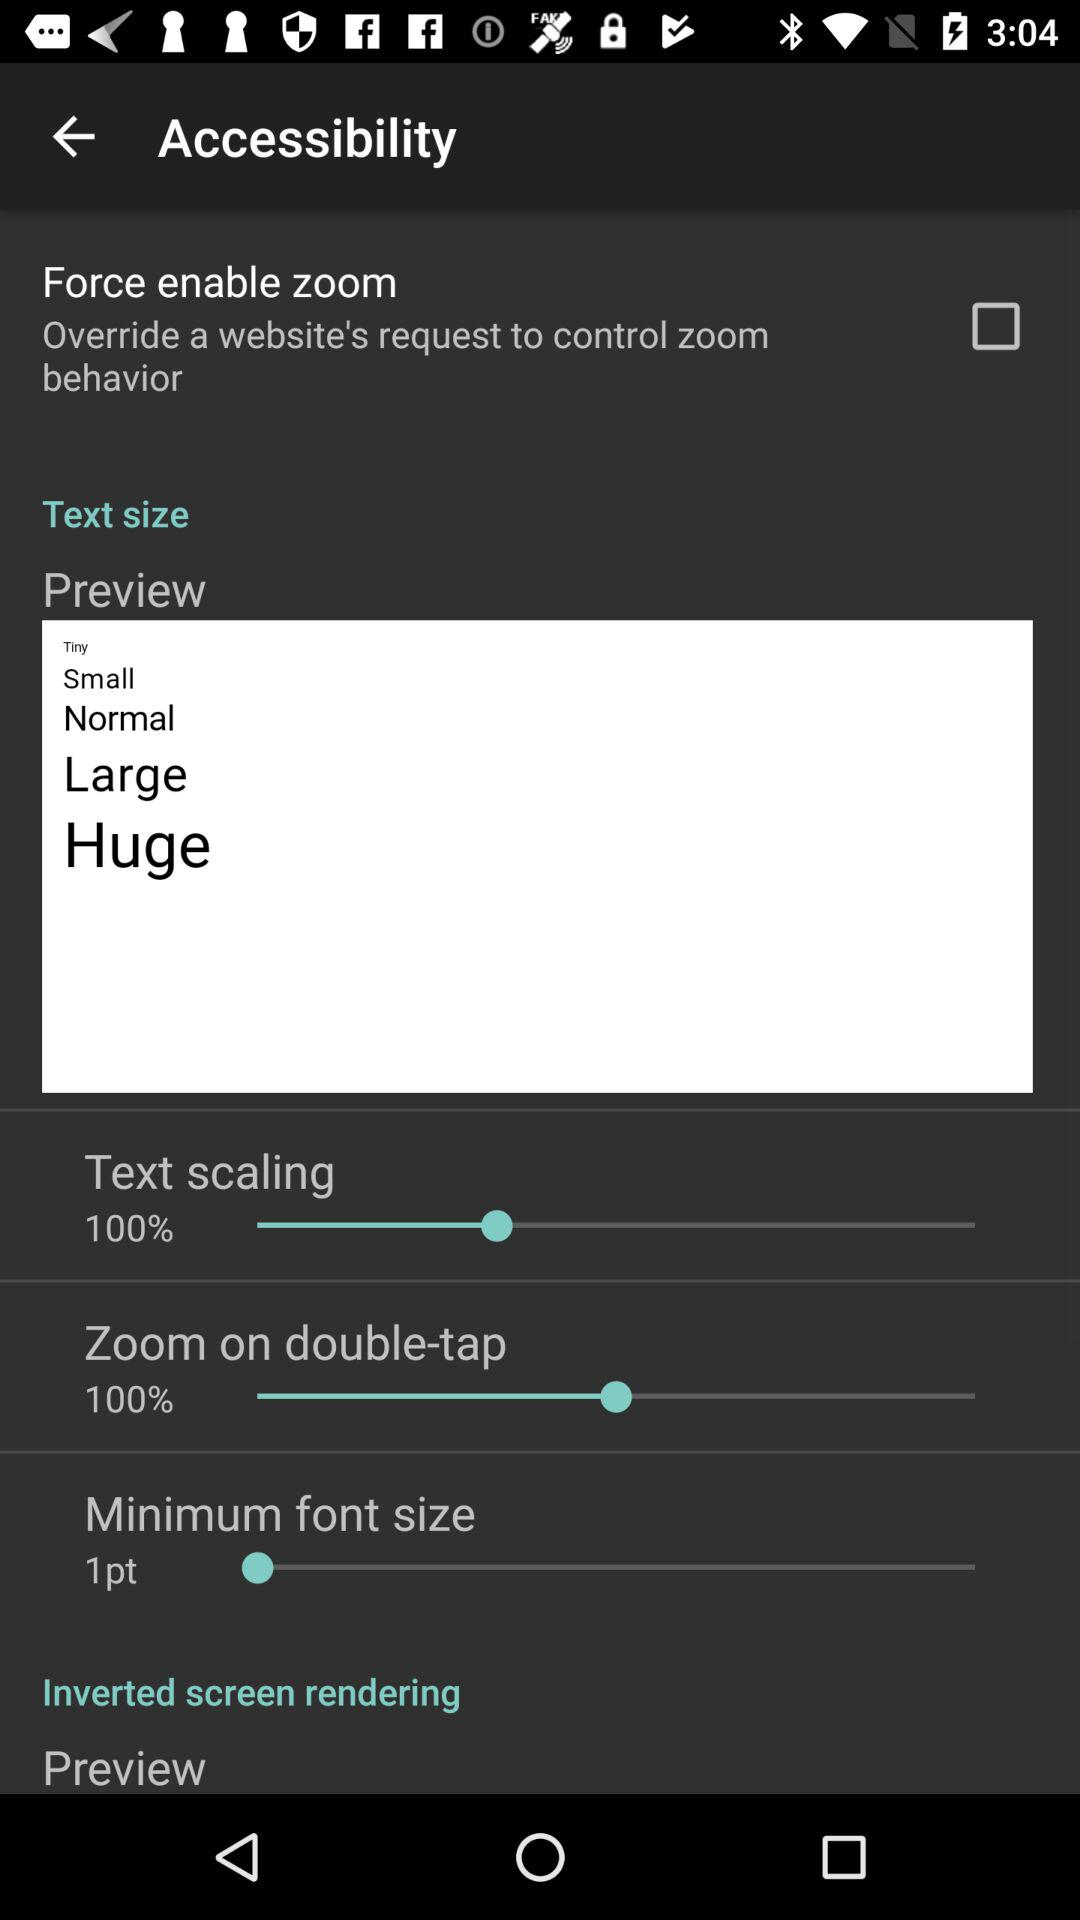What is the status of "Force enable zoom"? The status is off. 